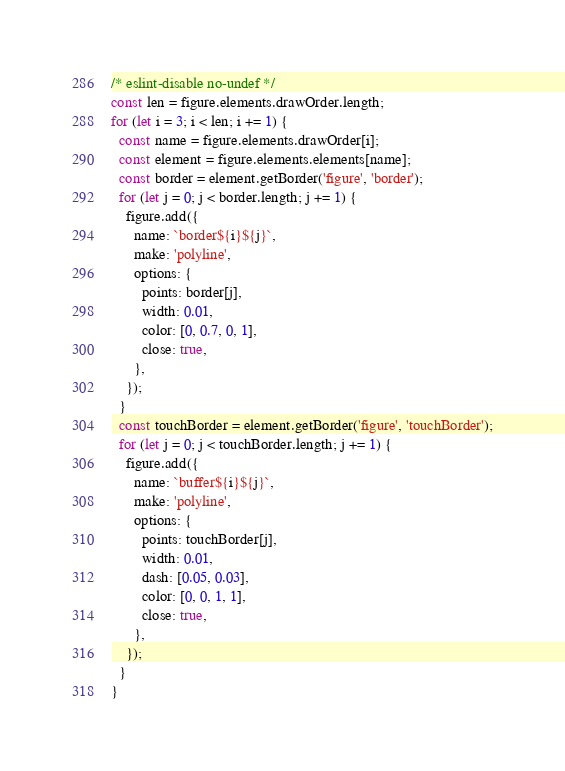Convert code to text. <code><loc_0><loc_0><loc_500><loc_500><_JavaScript_>/* eslint-disable no-undef */
const len = figure.elements.drawOrder.length;
for (let i = 3; i < len; i += 1) {
  const name = figure.elements.drawOrder[i];
  const element = figure.elements.elements[name];
  const border = element.getBorder('figure', 'border');
  for (let j = 0; j < border.length; j += 1) {
    figure.add({
      name: `border${i}${j}`,
      make: 'polyline',
      options: {
        points: border[j],
        width: 0.01,
        color: [0, 0.7, 0, 1],
        close: true,
      },
    });
  }
  const touchBorder = element.getBorder('figure', 'touchBorder');
  for (let j = 0; j < touchBorder.length; j += 1) {
    figure.add({
      name: `buffer${i}${j}`,
      make: 'polyline',
      options: {
        points: touchBorder[j],
        width: 0.01,
        dash: [0.05, 0.03],
        color: [0, 0, 1, 1],
        close: true,
      },
    });
  }
}

</code> 